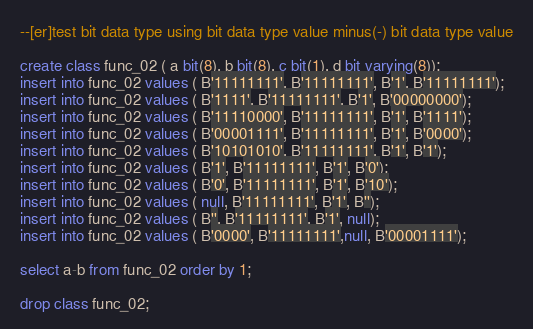Convert code to text. <code><loc_0><loc_0><loc_500><loc_500><_SQL_>--[er]test bit data type using bit data type value minus(-) bit data type value

create class func_02 ( a bit(8), b bit(8), c bit(1), d bit varying(8));
insert into func_02 values ( B'11111111', B'11111111', B'1', B'11111111');
insert into func_02 values ( B'1111', B'11111111', B'1', B'00000000');
insert into func_02 values ( B'11110000', B'11111111', B'1', B'1111');
insert into func_02 values ( B'00001111', B'11111111', B'1', B'0000');
insert into func_02 values ( B'10101010', B'11111111', B'1', B'1');
insert into func_02 values ( B'1', B'11111111', B'1', B'0');
insert into func_02 values ( B'0', B'11111111', B'1', B'10');
insert into func_02 values ( null, B'11111111', B'1', B'');
insert into func_02 values ( B'', B'11111111', B'1', null);
insert into func_02 values ( B'0000', B'11111111',null, B'00001111');

select a-b from func_02 order by 1;

drop class func_02;
</code> 